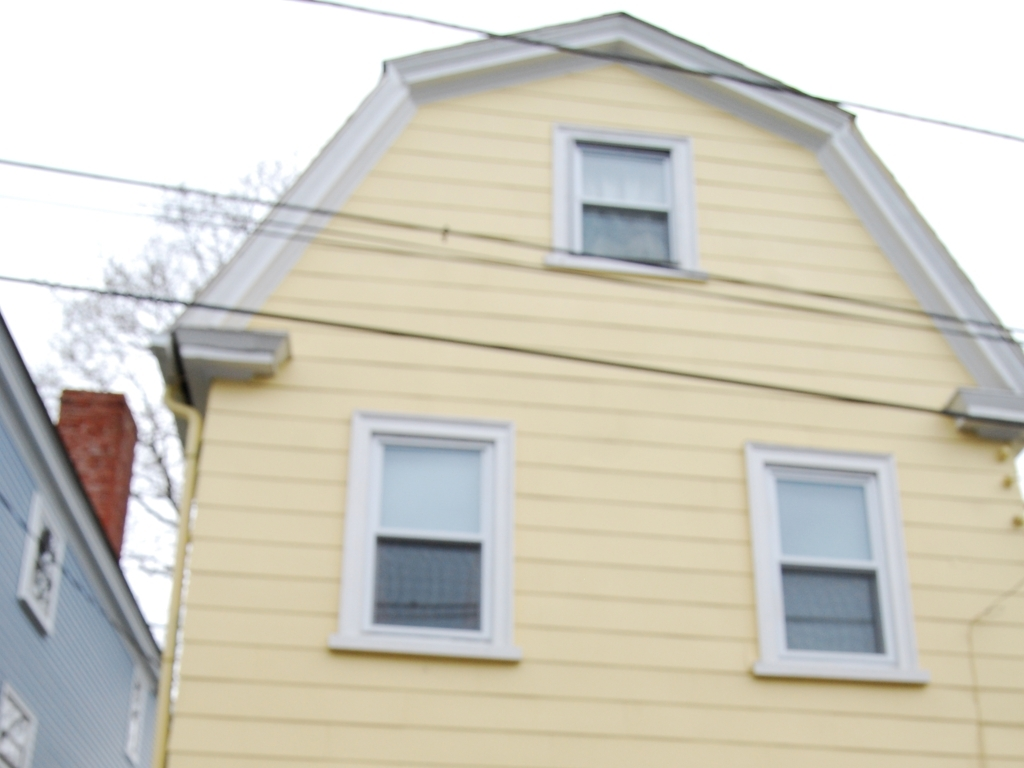Are there power lines obstructing the house? Yes, there are power lines in front of the house, slightly obstructing the view. These lines may contribute to a cluttered visual appearance and can be considered an impediment, depending on the viewer's perspective and the intended use of the view. 